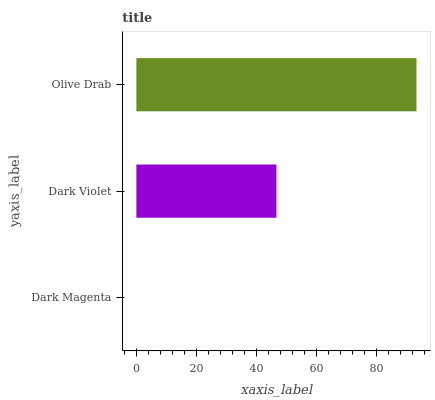Is Dark Magenta the minimum?
Answer yes or no. Yes. Is Olive Drab the maximum?
Answer yes or no. Yes. Is Dark Violet the minimum?
Answer yes or no. No. Is Dark Violet the maximum?
Answer yes or no. No. Is Dark Violet greater than Dark Magenta?
Answer yes or no. Yes. Is Dark Magenta less than Dark Violet?
Answer yes or no. Yes. Is Dark Magenta greater than Dark Violet?
Answer yes or no. No. Is Dark Violet less than Dark Magenta?
Answer yes or no. No. Is Dark Violet the high median?
Answer yes or no. Yes. Is Dark Violet the low median?
Answer yes or no. Yes. Is Dark Magenta the high median?
Answer yes or no. No. Is Olive Drab the low median?
Answer yes or no. No. 